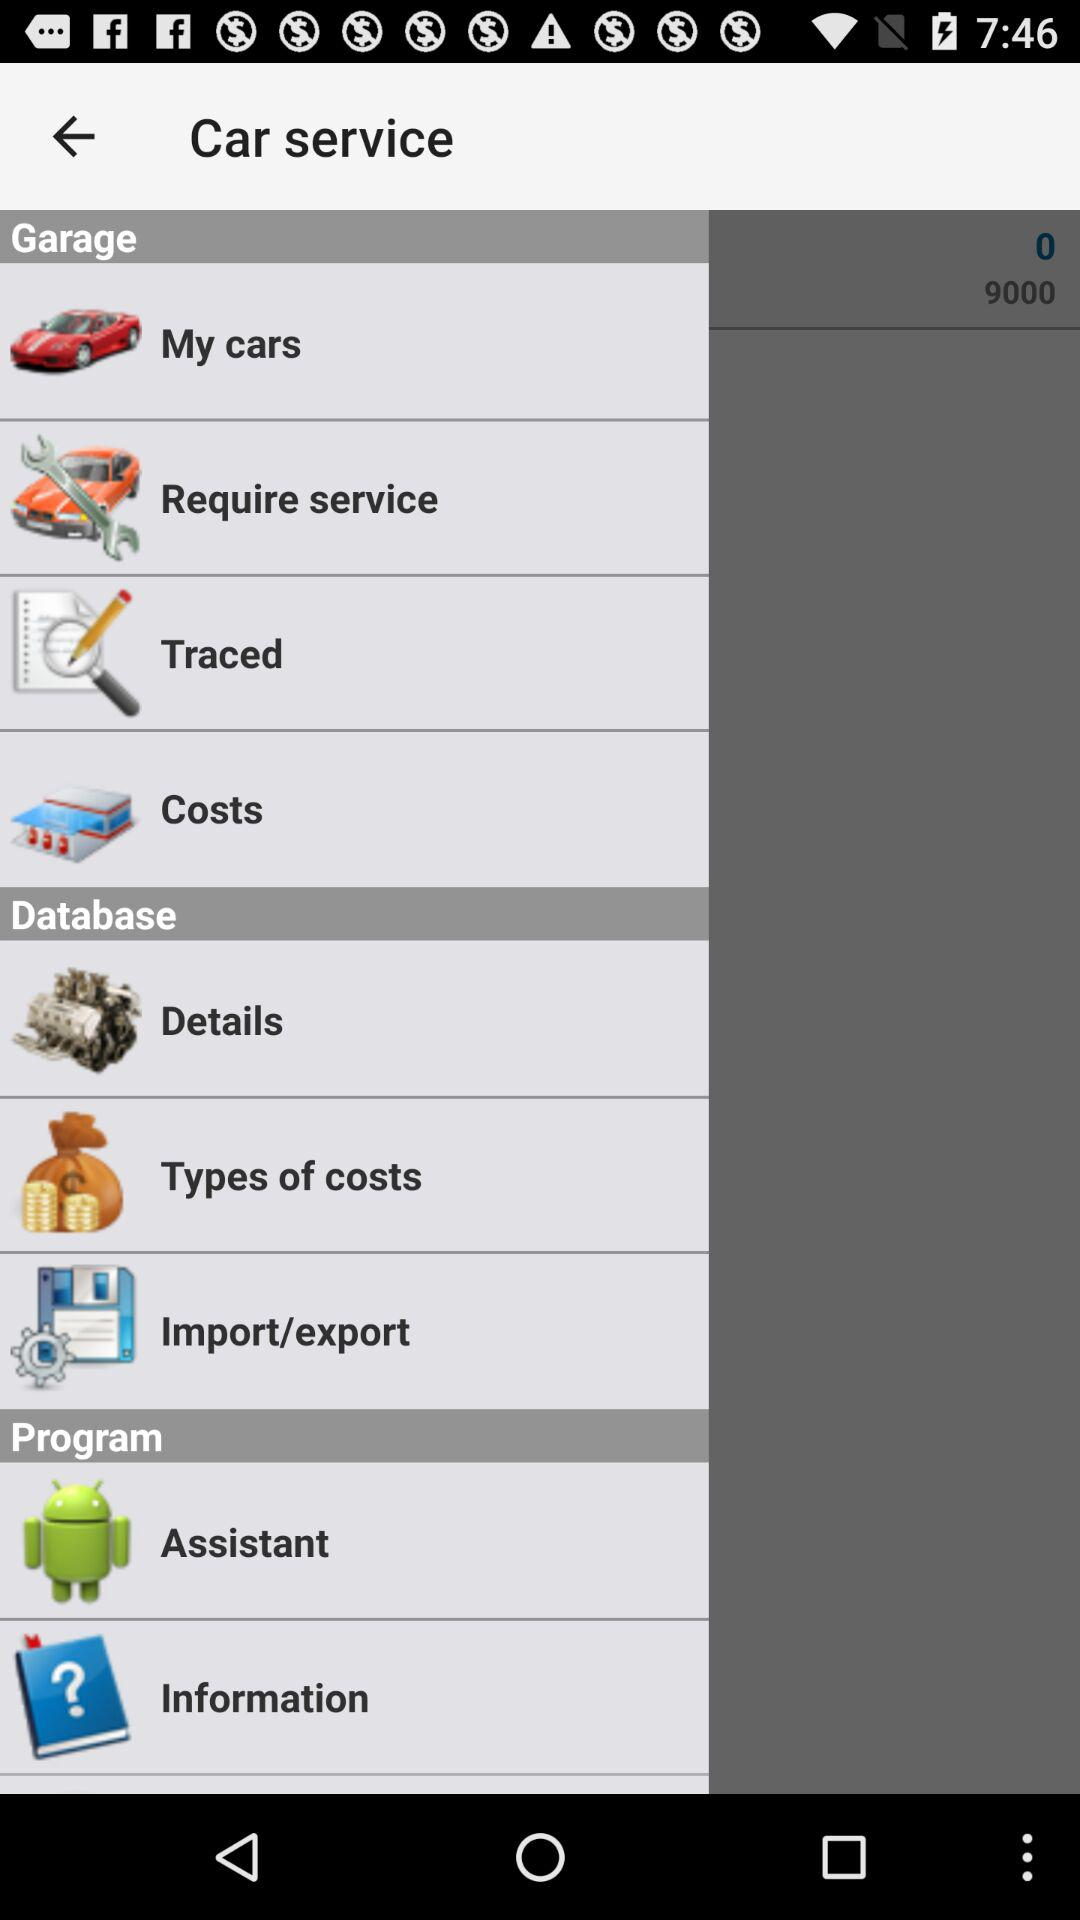What is the application name?
When the provided information is insufficient, respond with <no answer>. <no answer> 